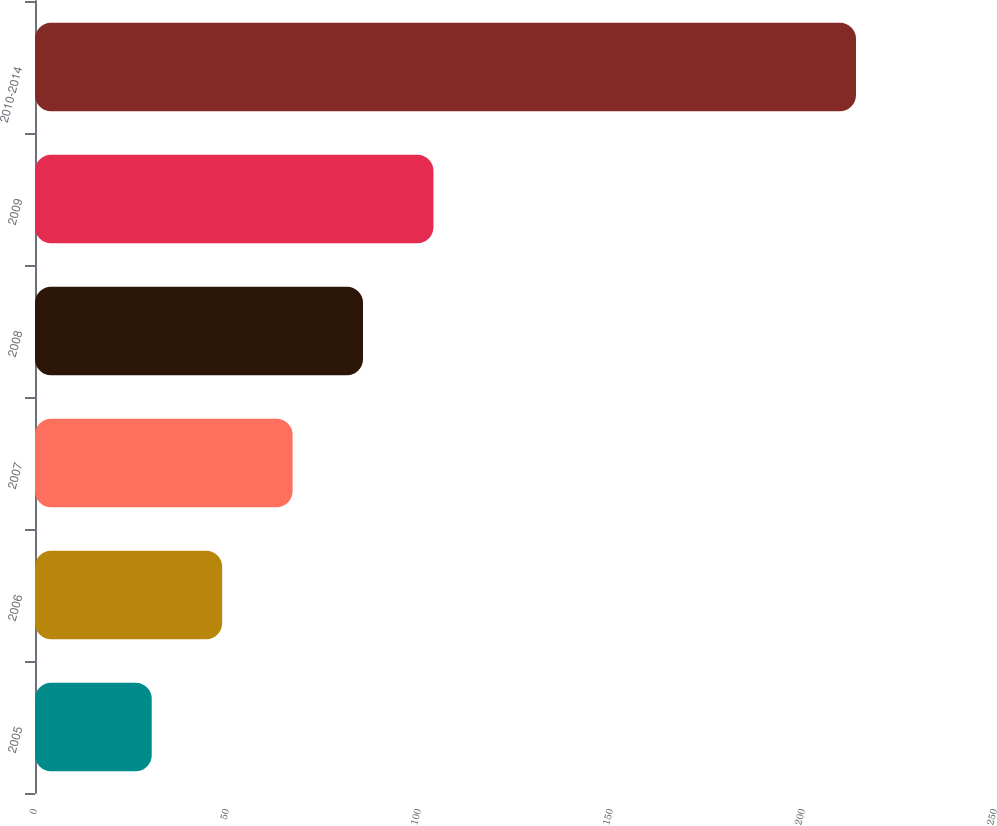Convert chart. <chart><loc_0><loc_0><loc_500><loc_500><bar_chart><fcel>2005<fcel>2006<fcel>2007<fcel>2008<fcel>2009<fcel>2010-2014<nl><fcel>30.4<fcel>48.74<fcel>67.08<fcel>85.42<fcel>103.76<fcel>213.8<nl></chart> 